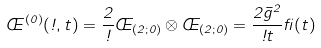Convert formula to latex. <formula><loc_0><loc_0><loc_500><loc_500>\phi ^ { ( 0 ) } ( \omega , t ) = \frac { 2 } { \omega } \phi _ { ( 2 ; 0 ) } \otimes \phi _ { ( 2 ; 0 ) } = \frac { 2 \bar { g } ^ { 2 } } { \omega t } \beta ( t )</formula> 